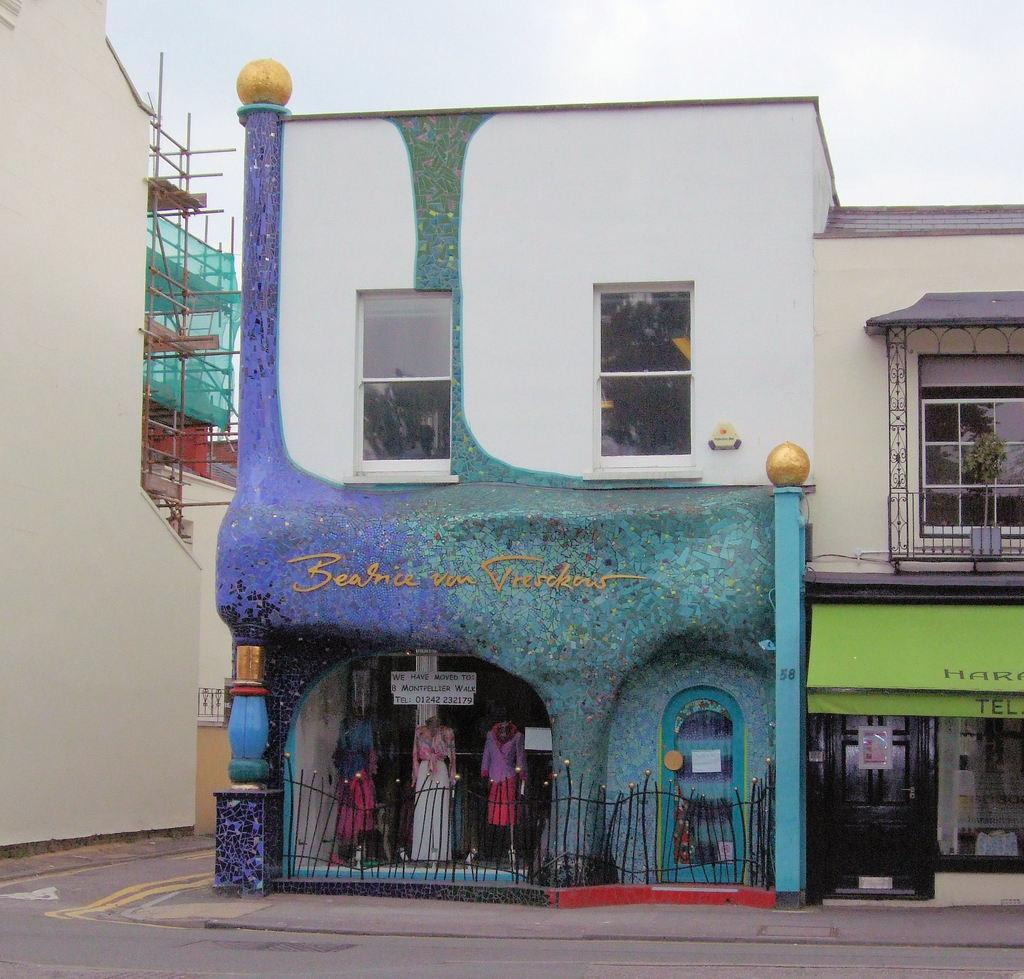What type of structures can be seen in the image? There are buildings in the image. Can you see the children playing under a veil in the image? There is no mention of children or a veil in the image; it only features buildings. 